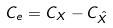Convert formula to latex. <formula><loc_0><loc_0><loc_500><loc_500>C _ { e } = C _ { X } - C _ { \hat { X } }</formula> 